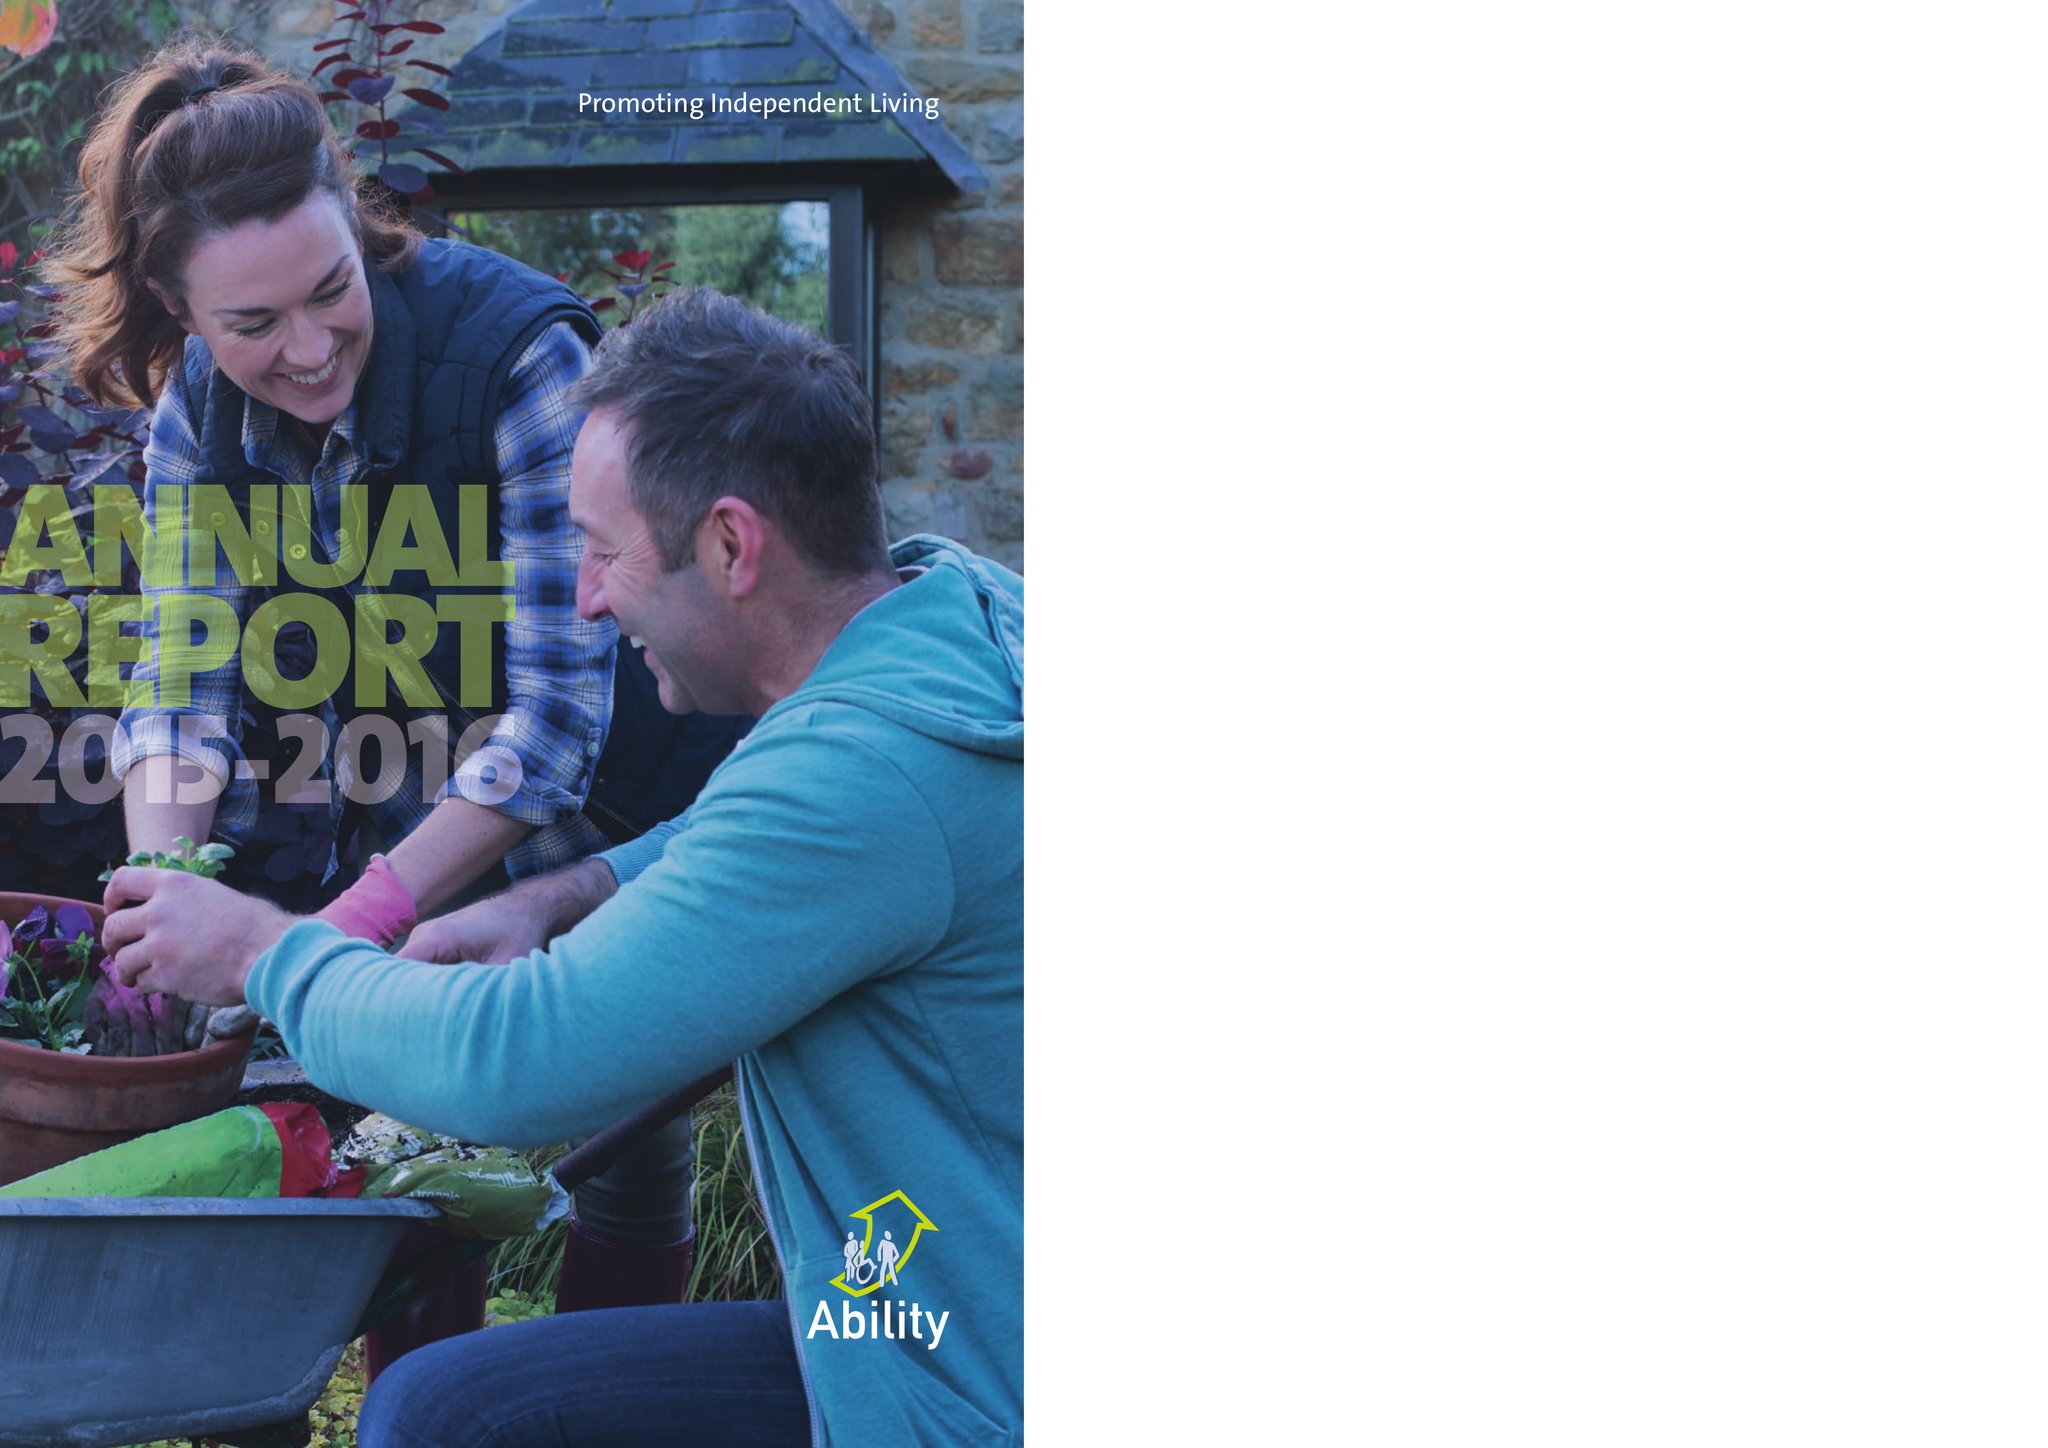What is the value for the address__street_line?
Answer the question using a single word or phrase. None 